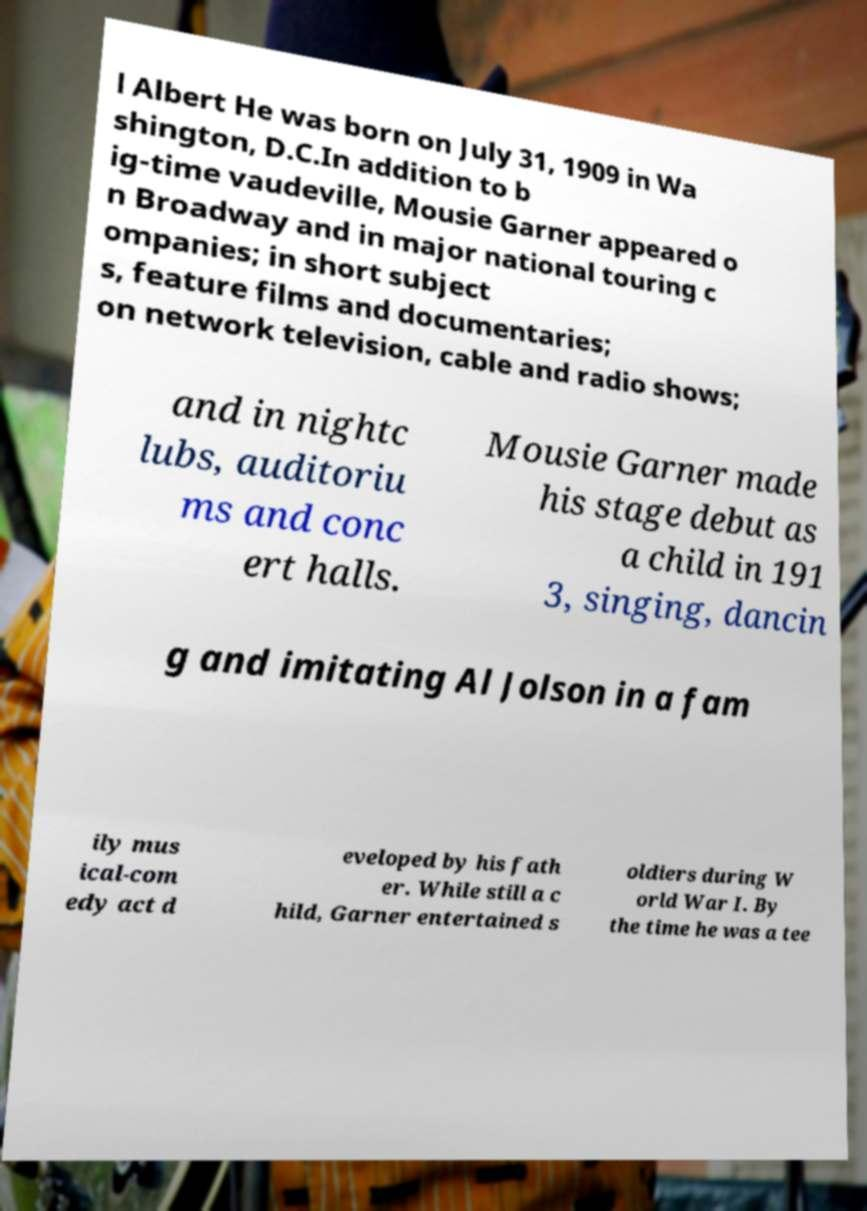There's text embedded in this image that I need extracted. Can you transcribe it verbatim? l Albert He was born on July 31, 1909 in Wa shington, D.C.In addition to b ig-time vaudeville, Mousie Garner appeared o n Broadway and in major national touring c ompanies; in short subject s, feature films and documentaries; on network television, cable and radio shows; and in nightc lubs, auditoriu ms and conc ert halls. Mousie Garner made his stage debut as a child in 191 3, singing, dancin g and imitating Al Jolson in a fam ily mus ical-com edy act d eveloped by his fath er. While still a c hild, Garner entertained s oldiers during W orld War I. By the time he was a tee 